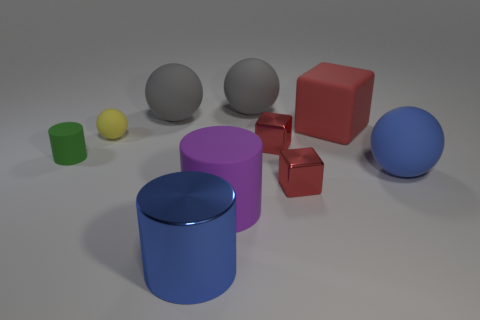How many red blocks must be subtracted to get 1 red blocks? 2 Subtract all green cubes. Subtract all brown spheres. How many cubes are left? 3 Subtract all cylinders. How many objects are left? 7 Add 1 big purple matte cylinders. How many big purple matte cylinders are left? 2 Add 3 yellow spheres. How many yellow spheres exist? 4 Subtract 0 green cubes. How many objects are left? 10 Subtract all big matte balls. Subtract all gray things. How many objects are left? 5 